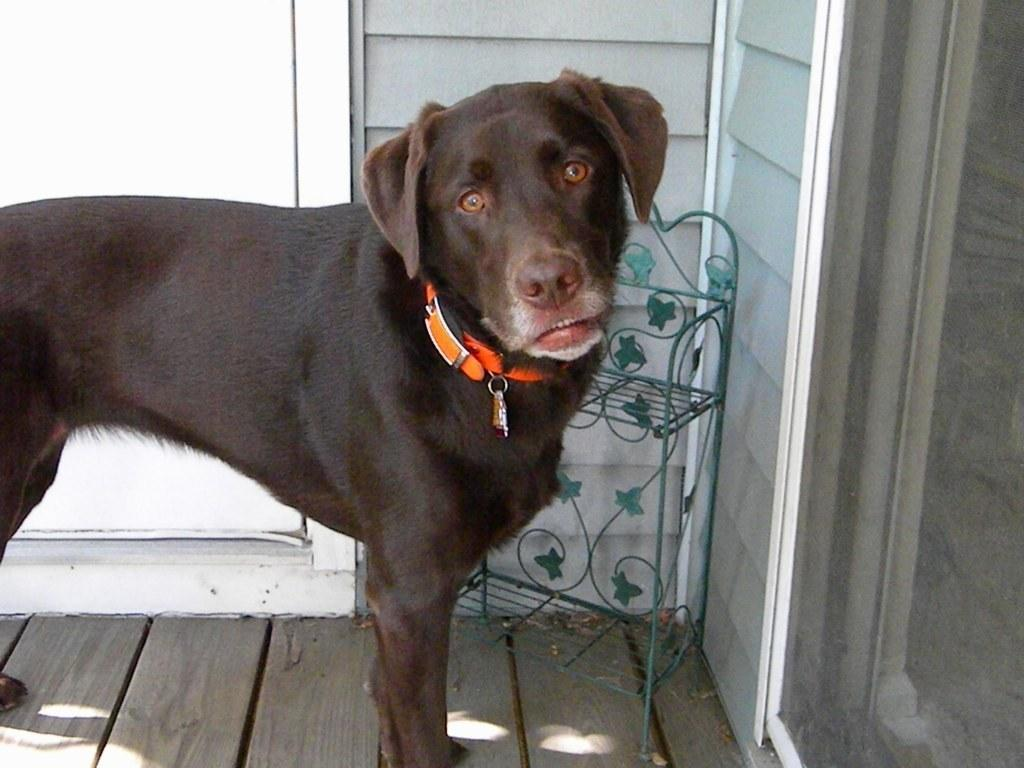What type of animal is in the image? There is a dog in the image. What surface is the dog standing on? The dog is on a wooden floor. What structure can be seen in the image? There is a stand in the image. What is the background of the image made of? There is a wall in the image. What type of object is made of glass? There is a glass object in the image. How does the worm contribute to the pollution in the image? There is no worm present in the image, and therefore no contribution to pollution can be observed. 